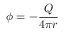Convert formula to latex. <formula><loc_0><loc_0><loc_500><loc_500>\phi = - { \frac { Q } { 4 \pi r } }</formula> 